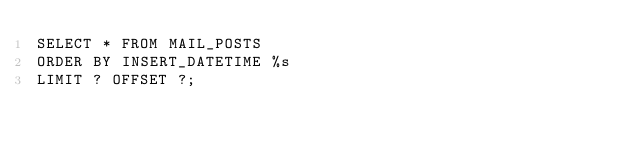Convert code to text. <code><loc_0><loc_0><loc_500><loc_500><_SQL_>SELECT * FROM MAIL_POSTS
ORDER BY INSERT_DATETIME %s
LIMIT ? OFFSET ?;
</code> 